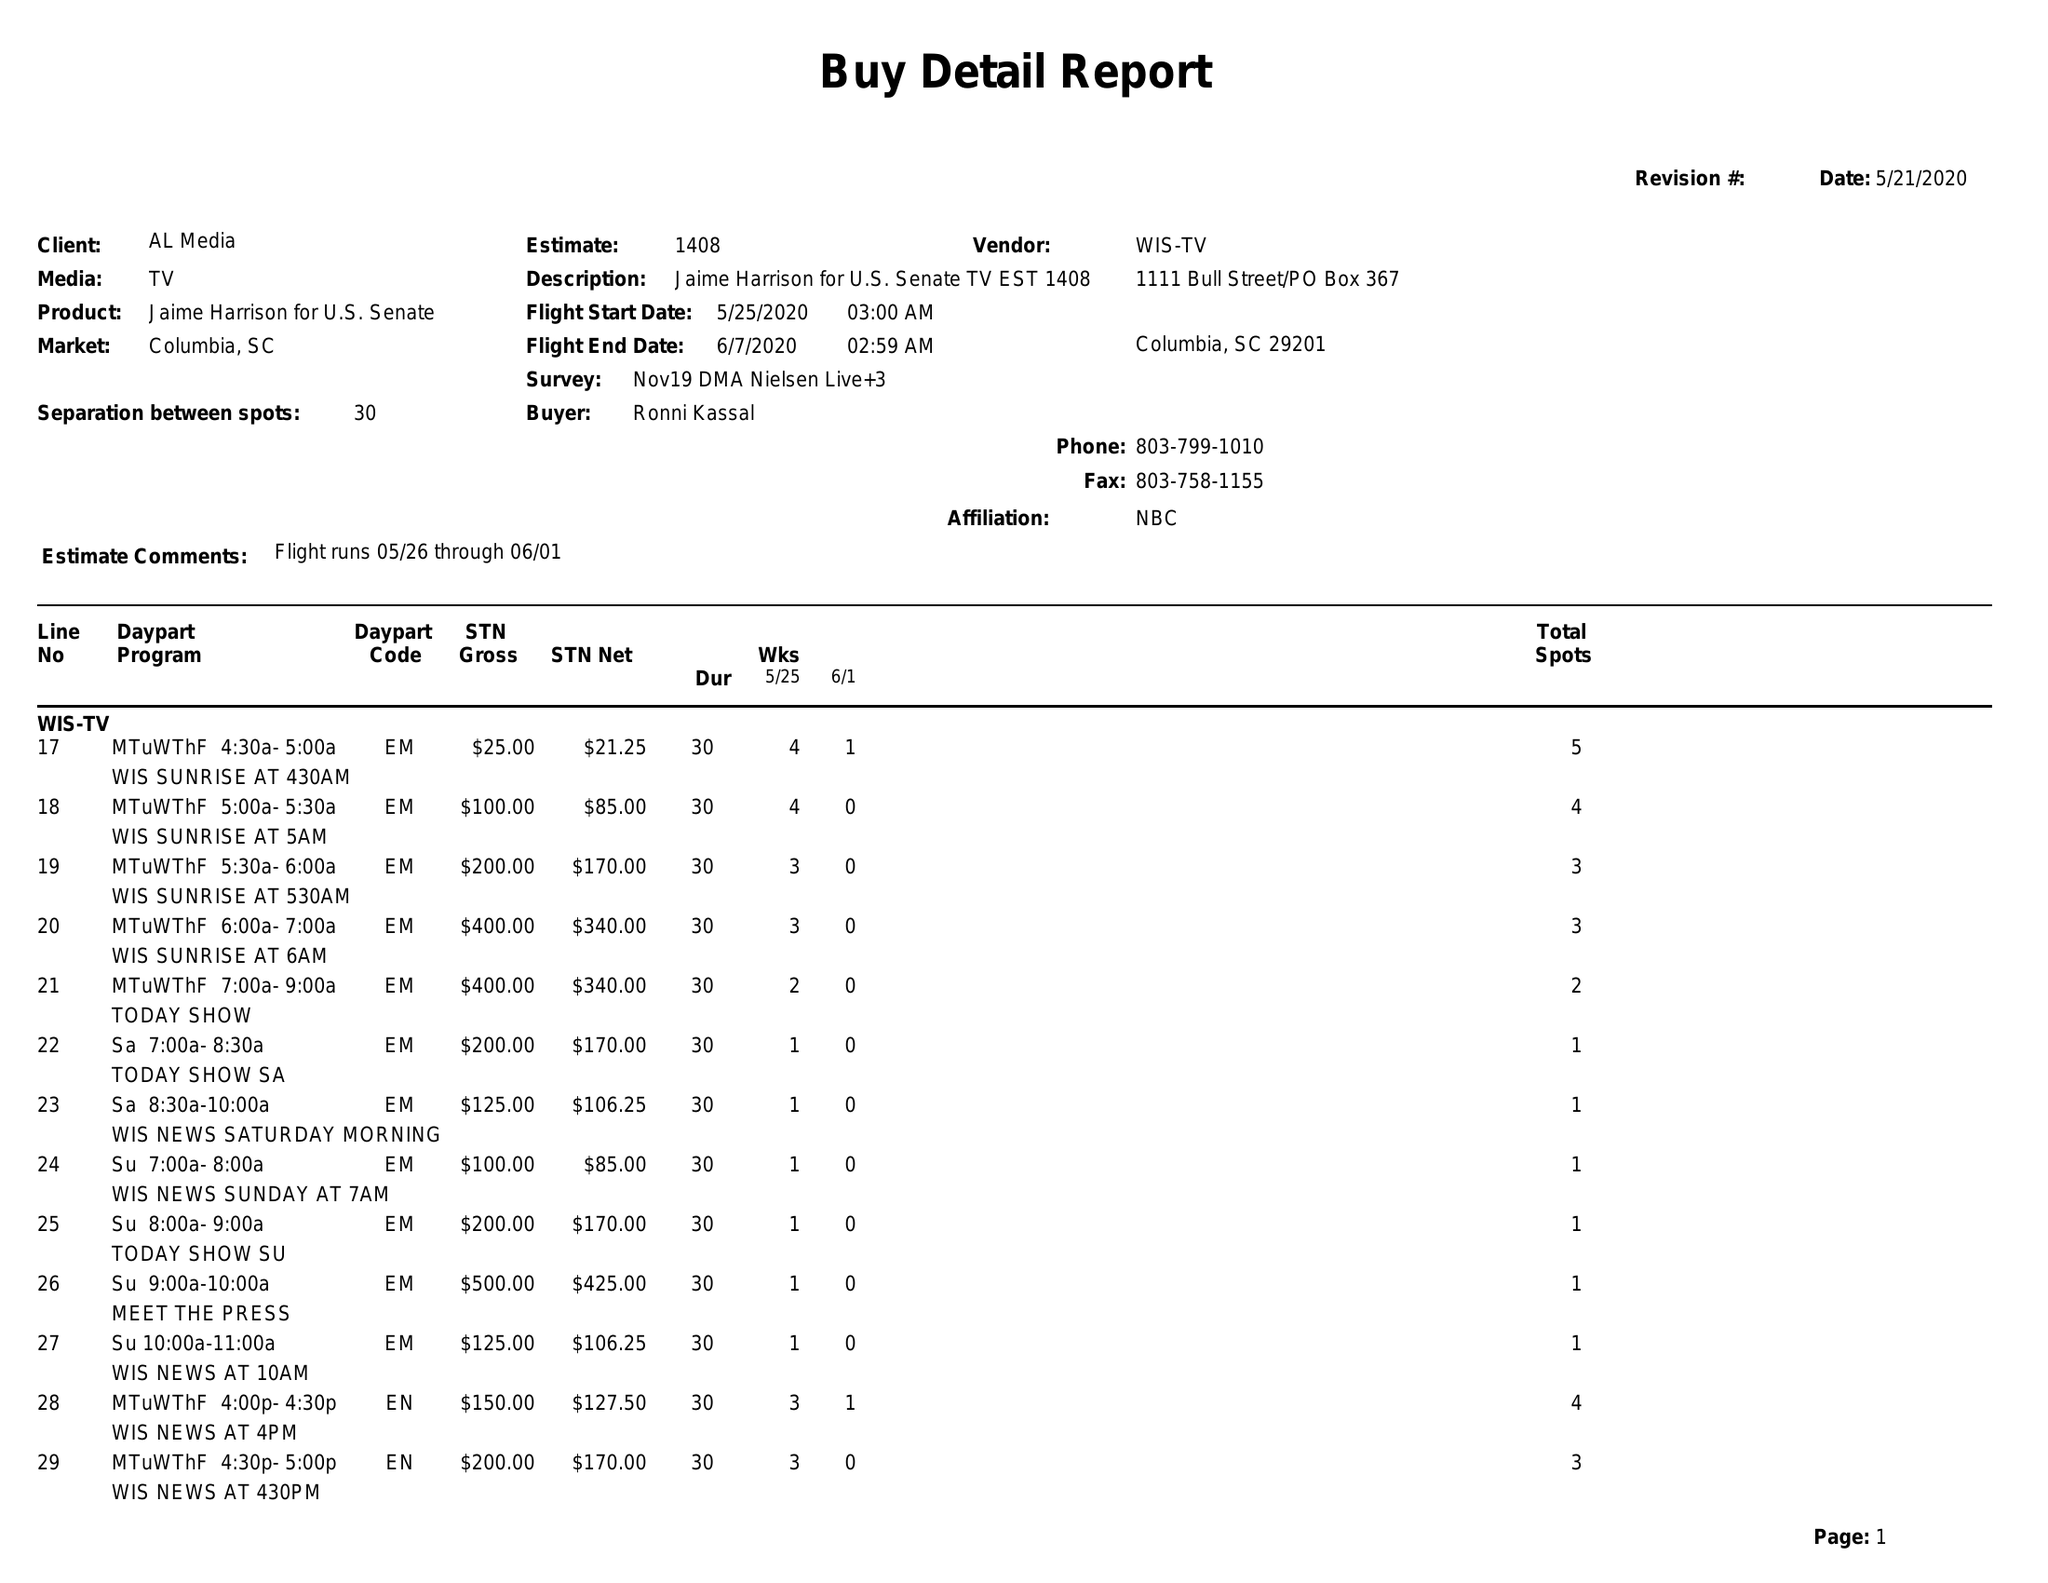What is the value for the advertiser?
Answer the question using a single word or phrase. JAIME HARRISON FOR U.S. SENATE 